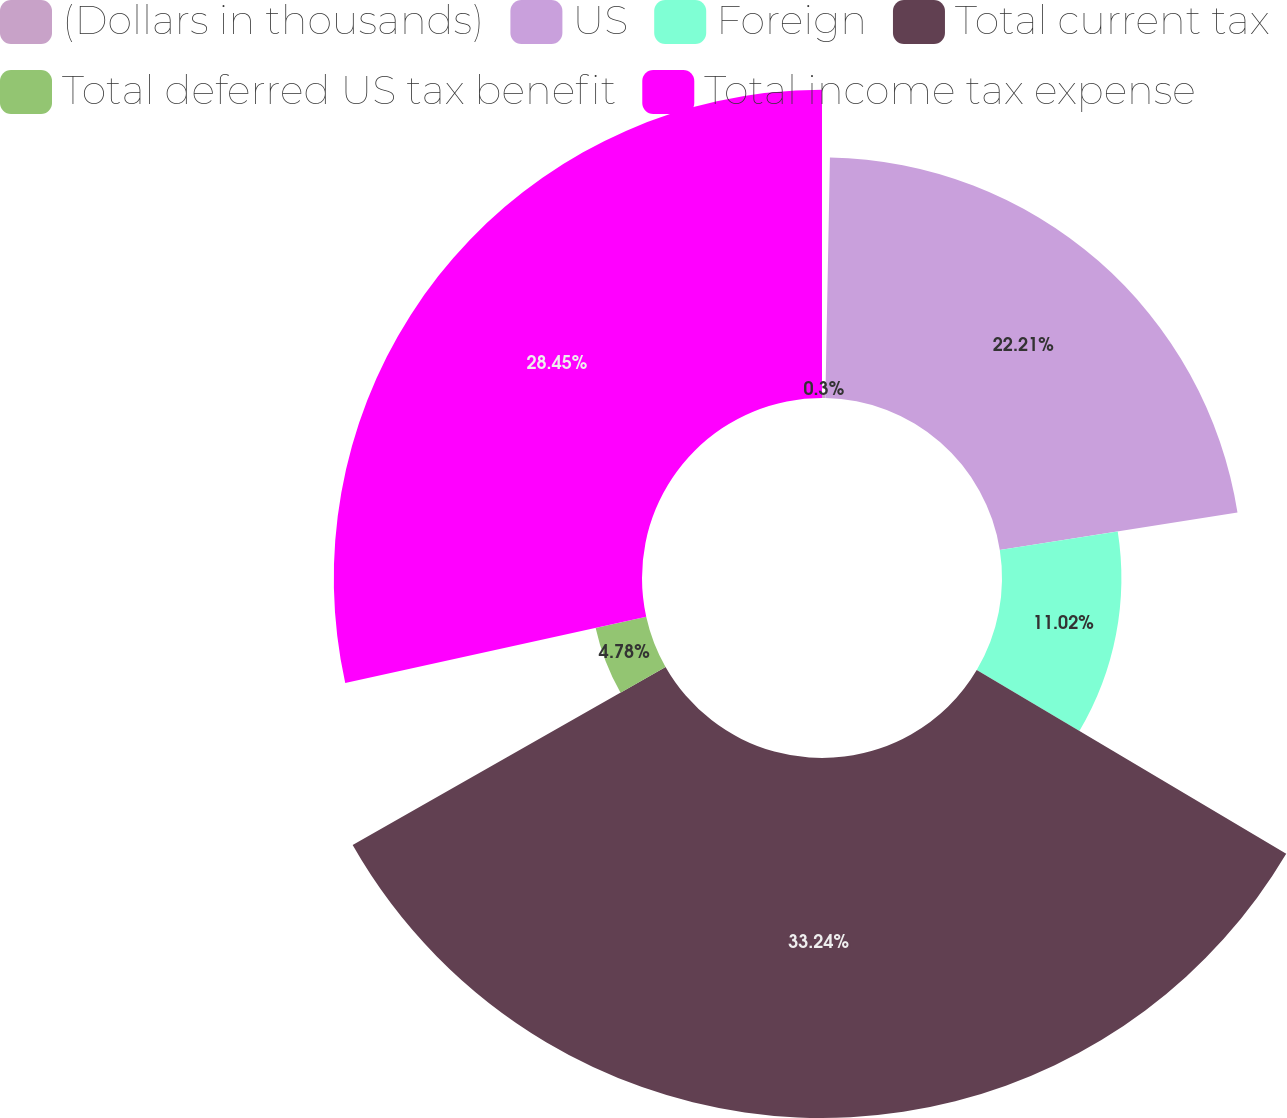Convert chart. <chart><loc_0><loc_0><loc_500><loc_500><pie_chart><fcel>(Dollars in thousands)<fcel>US<fcel>Foreign<fcel>Total current tax<fcel>Total deferred US tax benefit<fcel>Total income tax expense<nl><fcel>0.3%<fcel>22.21%<fcel>11.02%<fcel>33.23%<fcel>4.78%<fcel>28.45%<nl></chart> 